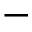Convert formula to latex. <formula><loc_0><loc_0><loc_500><loc_500>-</formula> 